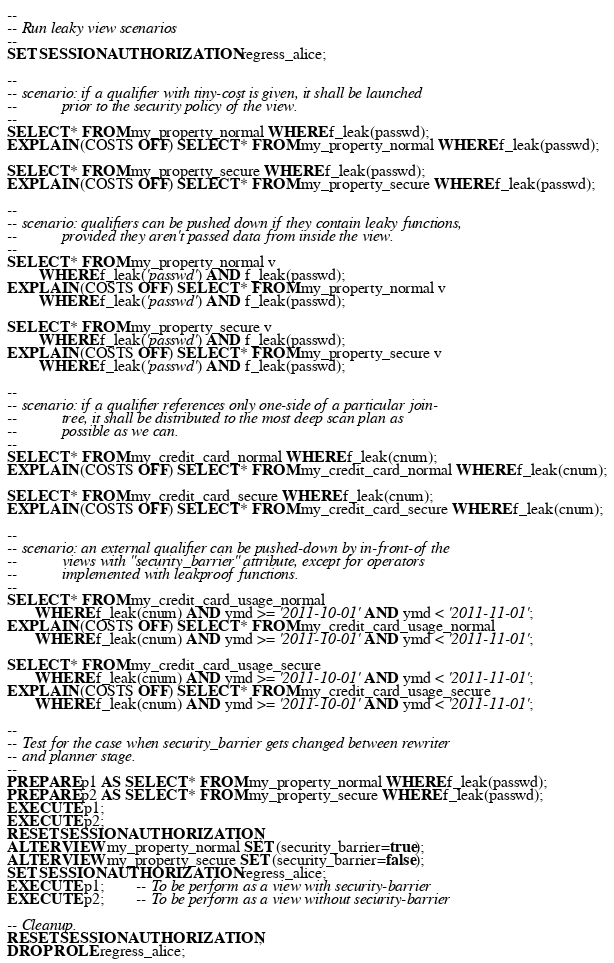<code> <loc_0><loc_0><loc_500><loc_500><_SQL_>
--
-- Run leaky view scenarios
--
SET SESSION AUTHORIZATION regress_alice;

--
-- scenario: if a qualifier with tiny-cost is given, it shall be launched
--           prior to the security policy of the view.
--
SELECT * FROM my_property_normal WHERE f_leak(passwd);
EXPLAIN (COSTS OFF) SELECT * FROM my_property_normal WHERE f_leak(passwd);

SELECT * FROM my_property_secure WHERE f_leak(passwd);
EXPLAIN (COSTS OFF) SELECT * FROM my_property_secure WHERE f_leak(passwd);

--
-- scenario: qualifiers can be pushed down if they contain leaky functions,
--           provided they aren't passed data from inside the view.
--
SELECT * FROM my_property_normal v
		WHERE f_leak('passwd') AND f_leak(passwd);
EXPLAIN (COSTS OFF) SELECT * FROM my_property_normal v
		WHERE f_leak('passwd') AND f_leak(passwd);

SELECT * FROM my_property_secure v
		WHERE f_leak('passwd') AND f_leak(passwd);
EXPLAIN (COSTS OFF) SELECT * FROM my_property_secure v
		WHERE f_leak('passwd') AND f_leak(passwd);

--
-- scenario: if a qualifier references only one-side of a particular join-
--           tree, it shall be distributed to the most deep scan plan as
--           possible as we can.
--
SELECT * FROM my_credit_card_normal WHERE f_leak(cnum);
EXPLAIN (COSTS OFF) SELECT * FROM my_credit_card_normal WHERE f_leak(cnum);

SELECT * FROM my_credit_card_secure WHERE f_leak(cnum);
EXPLAIN (COSTS OFF) SELECT * FROM my_credit_card_secure WHERE f_leak(cnum);

--
-- scenario: an external qualifier can be pushed-down by in-front-of the
--           views with "security_barrier" attribute, except for operators
--           implemented with leakproof functions.
--
SELECT * FROM my_credit_card_usage_normal
       WHERE f_leak(cnum) AND ymd >= '2011-10-01' AND ymd < '2011-11-01';
EXPLAIN (COSTS OFF) SELECT * FROM my_credit_card_usage_normal
       WHERE f_leak(cnum) AND ymd >= '2011-10-01' AND ymd < '2011-11-01';

SELECT * FROM my_credit_card_usage_secure
       WHERE f_leak(cnum) AND ymd >= '2011-10-01' AND ymd < '2011-11-01';
EXPLAIN (COSTS OFF) SELECT * FROM my_credit_card_usage_secure
       WHERE f_leak(cnum) AND ymd >= '2011-10-01' AND ymd < '2011-11-01';

--
-- Test for the case when security_barrier gets changed between rewriter
-- and planner stage.
--
PREPARE p1 AS SELECT * FROM my_property_normal WHERE f_leak(passwd);
PREPARE p2 AS SELECT * FROM my_property_secure WHERE f_leak(passwd);
EXECUTE p1;
EXECUTE p2;
RESET SESSION AUTHORIZATION;
ALTER VIEW my_property_normal SET (security_barrier=true);
ALTER VIEW my_property_secure SET (security_barrier=false);
SET SESSION AUTHORIZATION regress_alice;
EXECUTE p1;		-- To be perform as a view with security-barrier
EXECUTE p2;		-- To be perform as a view without security-barrier

-- Cleanup.
RESET SESSION AUTHORIZATION;
DROP ROLE regress_alice;
</code> 